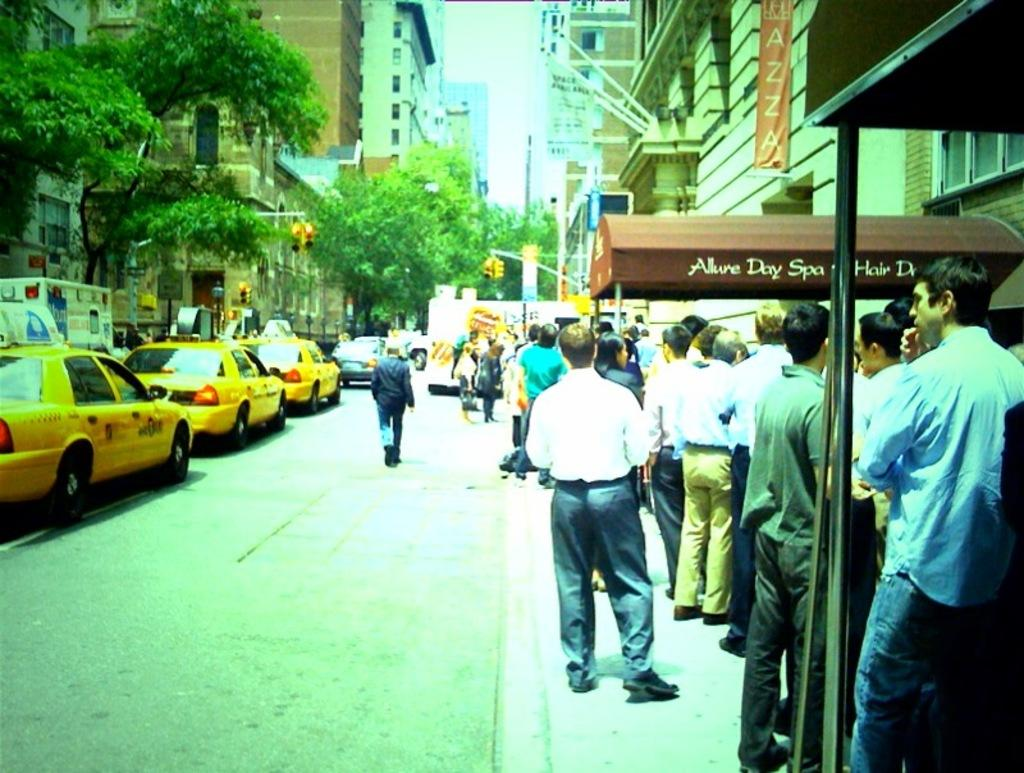<image>
Summarize the visual content of the image. alot of people standing outside of the allure day spa 